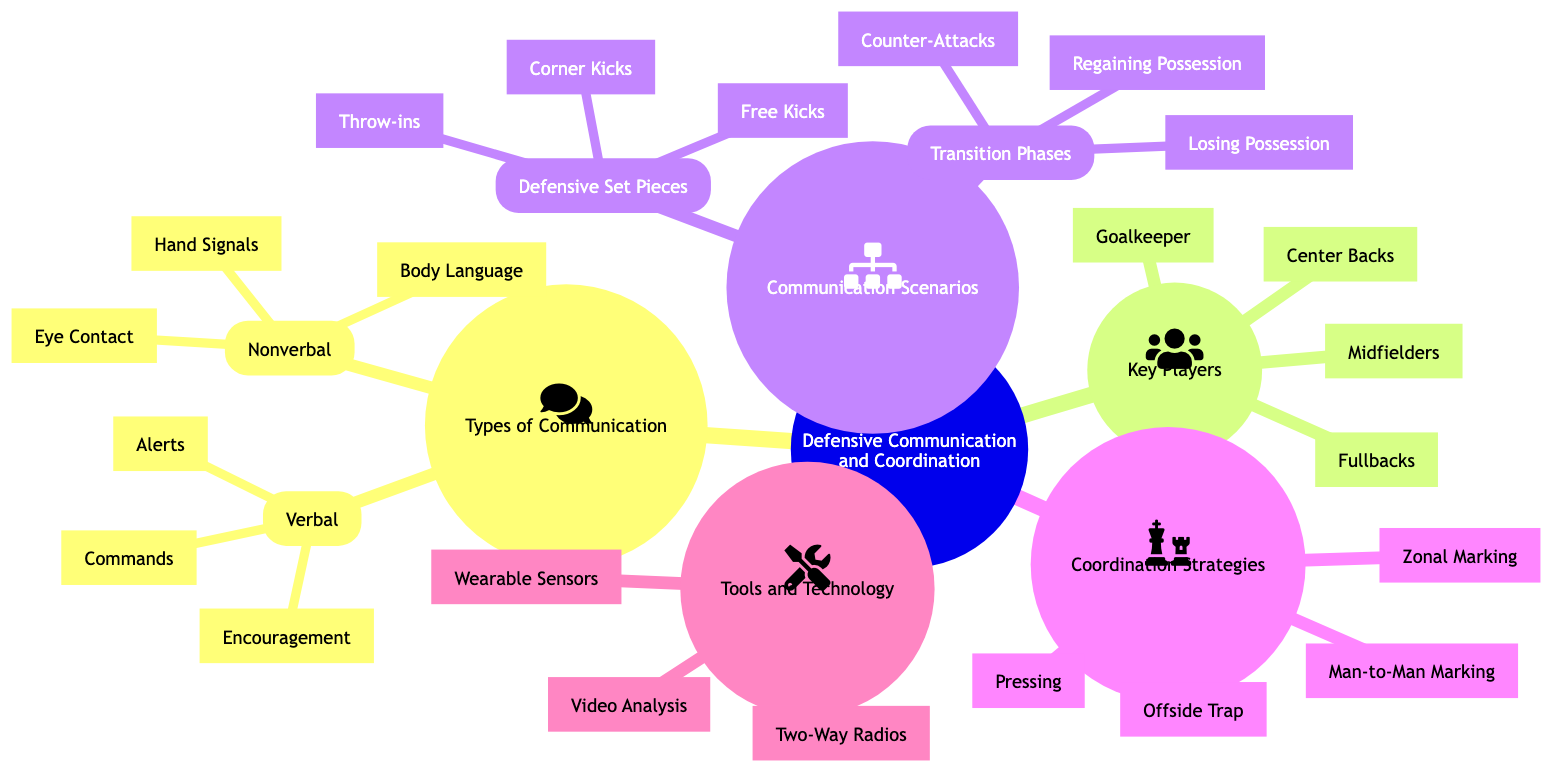What are the two main types of communication in the diagram? The diagram lists "Verbal Communication" and "Nonverbal Communication" as the two main types under "Types of Communication."
Answer: Verbal Communication, Nonverbal Communication How many elements are listed under Nonverbal Communication? Under the "Nonverbal Communication" node, there are three elements: "Hand Signals," "Eye Contact," and "Body Language." Counting these gives a total of three.
Answer: 3 Which key player is not a defender? The "Key Players" section lists four players: "Goalkeeper," "Center Backs," "Fullbacks," and "Midfielders." "Goalkeeper" is the only player whose primary role is not as a defender.
Answer: Goalkeeper What are the two scenarios listed for "Transition Phases"? The "Transition Phases" node includes three scenarios: "Counter-Attacks," "Regaining Possession," and "Losing Possession." However, the question specifies two which can be any two scenarios listed.
Answer: Counter-Attacks, Regaining Possession (or any other combination) What are the four strategies mentioned in Coordination Strategies? The "Coordination Strategies" node lists four strategies: "Zonal Marking," "Man-to-Man Marking," "Pressing," and "Offside Trap." All four are to be mentioned as they are included in the diagram.
Answer: Zonal Marking, Man-to-Man Marking, Pressing, Offside Trap Which tool is used for real-time communication among players? The "Tools and Technology" section identifies "Two-Way Radios" as a tool intended for immediate communication among players during the game.
Answer: Two-Way Radios How many elements are under Defensive Set Pieces? There are three elements listed under "Defensive Set Pieces," which include "Corner Kicks," "Free Kicks," and "Throw-ins." By counting them, we find that there are three.
Answer: 3 Are "Corner Kicks" categorized under Communication Scenarios or Coordination Strategies? The diagram places "Corner Kicks" under the "Communication Scenarios," specifically within the "Defensive Set Pieces" category.
Answer: Communication Scenarios What type of marking does "Offside Trap" represent? "Offside Trap" is listed among the "Coordination Strategies" which is a defensive tactic that relates specifically to positioning against attackers.
Answer: Coordination Strategies 